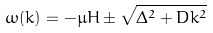<formula> <loc_0><loc_0><loc_500><loc_500>\omega ( k ) = - \mu H \pm \sqrt { \Delta ^ { 2 } + D k ^ { 2 } }</formula> 